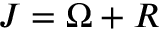Convert formula to latex. <formula><loc_0><loc_0><loc_500><loc_500>J = \Omega + R</formula> 